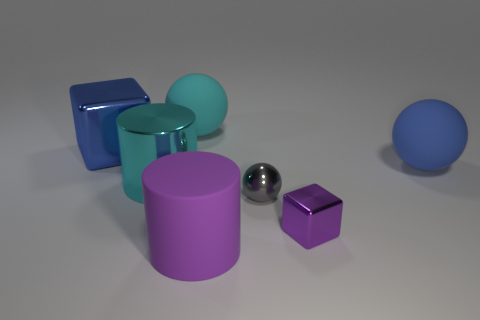Is the number of spheres less than the number of big purple rubber cylinders?
Ensure brevity in your answer.  No. Do the cyan sphere and the block on the right side of the large cyan rubber thing have the same material?
Keep it short and to the point. No. There is a large blue object that is right of the gray shiny ball; what shape is it?
Your answer should be very brief. Sphere. Is there any other thing of the same color as the shiny ball?
Provide a short and direct response. No. Is the number of big blue rubber things in front of the large cyan rubber thing less than the number of big green spheres?
Make the answer very short. No. How many brown matte spheres have the same size as the blue ball?
Your answer should be very brief. 0. There is a rubber object that is the same color as the large block; what is its shape?
Your answer should be compact. Sphere. The small metal object on the left side of the purple block that is on the left side of the blue object that is in front of the blue block is what shape?
Your response must be concise. Sphere. The cube right of the small shiny sphere is what color?
Give a very brief answer. Purple. What number of objects are either matte things behind the large cyan metallic object or metal things on the left side of the small gray thing?
Give a very brief answer. 4. 